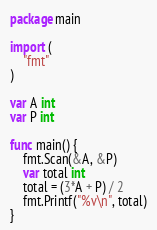<code> <loc_0><loc_0><loc_500><loc_500><_Go_>package main

import (
	"fmt"
)

var A int
var P int

func main() {
	fmt.Scan(&A, &P)
	var total int
	total = (3*A + P) / 2
	fmt.Printf("%v\n", total)
}
</code> 